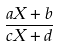Convert formula to latex. <formula><loc_0><loc_0><loc_500><loc_500>\frac { a X + b } { c X + d }</formula> 